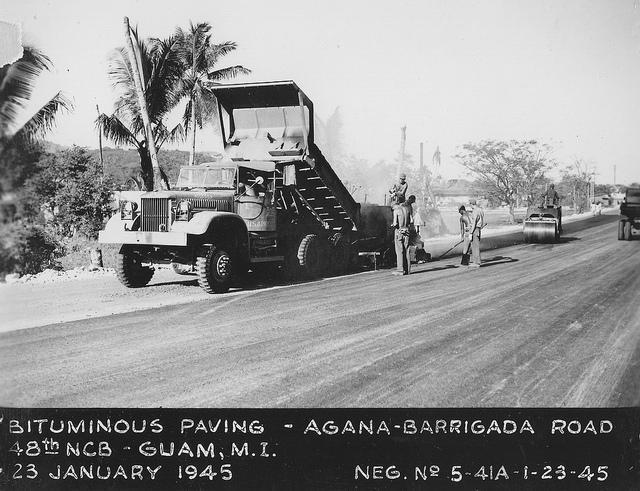How many red cars on the left?
Give a very brief answer. 0. 